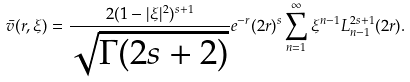<formula> <loc_0><loc_0><loc_500><loc_500>\bar { v } ( r , \xi ) = \frac { 2 ( 1 - | \xi | ^ { 2 } ) ^ { s + 1 } } { \sqrt { \Gamma ( 2 s + 2 ) } } e ^ { - r } ( 2 r ) ^ { s } \sum _ { n = 1 } ^ { \infty } \xi ^ { n - 1 } L _ { n - 1 } ^ { 2 s + 1 } ( 2 r ) .</formula> 